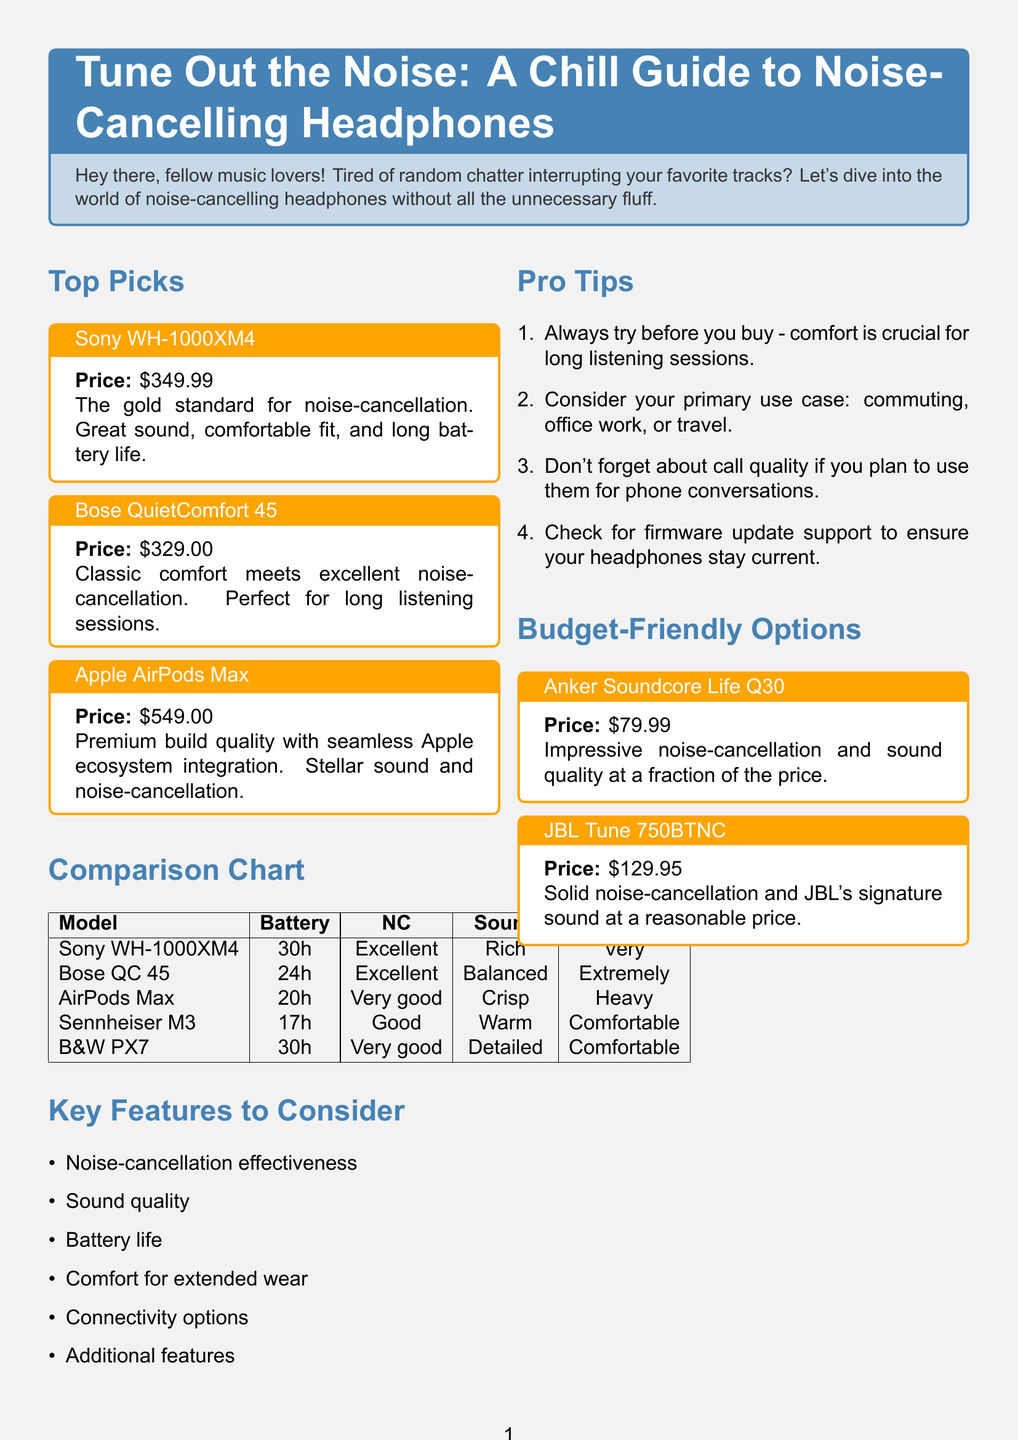What is the price of Sony WH-1000XM4? The price is indicated in the document under the product section for Sony WH-1000XM4, which states "$349.99".
Answer: $349.99 How long is the battery life of Bose QuietComfort 45? The battery life is detailed in the comparison chart where Bose QuietComfort 45 shows "24 hours".
Answer: 24 hours Which headphone has the best noise-cancellation? The document ranks noise-cancellation effectiveness in the comparison chart, listing "Excellent" for Sony WH-1000XM4 and Bose QuietComfort 45.
Answer: Sony WH-1000XM4, Bose QuietComfort 45 What should you do before buying headphones? The tips mention that one should "Always try before you buy" to ensure comfort.
Answer: Always try before you buy What is the price of the most budget-friendly option? The budget-friendly options list prices, with Anker Soundcore Life Q30 being priced at "$79.99".
Answer: $79.99 Which headphones were described as heavy in comfort? The document lists the comfort ratings, where Apple AirPods Max is noted as "Comfortable but heavy".
Answer: Apple AirPods Max Which headphone has a battery life of 30 hours? The comparison chart shows both Sony WH-1000XM4 and Bowers & Wilkins PX7 with a battery life of "30 hours".
Answer: Sony WH-1000XM4, Bowers & Wilkins PX7 Name one key feature to consider when buying noise-cancelling headphones. The "Key Features to Consider" section lists several features, such as "Noise-cancellation effectiveness".
Answer: Noise-cancellation effectiveness 